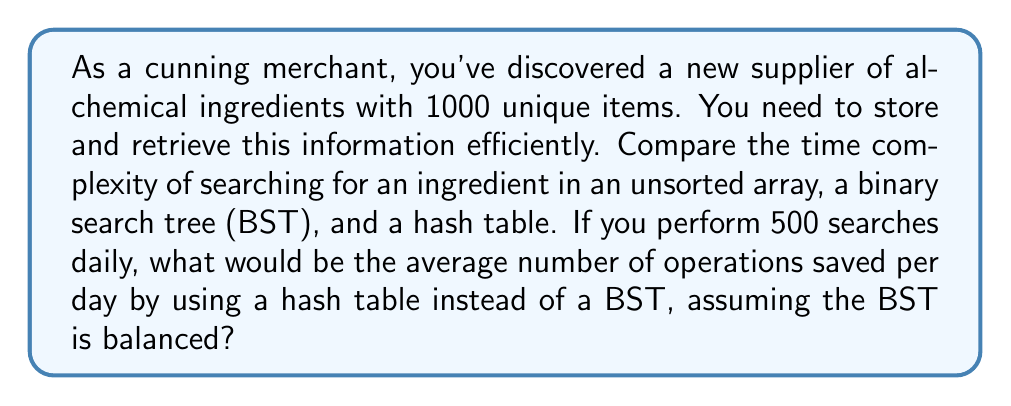Can you answer this question? Let's analyze the time complexities for each data structure:

1. Unsorted Array:
   - Search: $O(n)$, where $n$ is the number of elements (1000 in this case)

2. Binary Search Tree (BST):
   - Search: $O(\log n)$ for a balanced BST

3. Hash Table:
   - Search: $O(1)$ average case, assuming a good hash function and load factor

To calculate the average number of operations saved per day:

1. BST operations:
   - Each search takes $O(\log n) = O(\log 1000) \approx O(10)$ operations
   - Total operations per day: $500 \times 10 = 5000$

2. Hash Table operations:
   - Each search takes $O(1)$ operation
   - Total operations per day: $500 \times 1 = 500$

3. Operations saved:
   $$\text{Operations saved} = \text{BST operations} - \text{Hash Table operations}$$
   $$= 5000 - 500 = 4500$$

Therefore, using a hash table instead of a BST would save an average of 4500 operations per day.
Answer: 4500 operations saved per day on average 